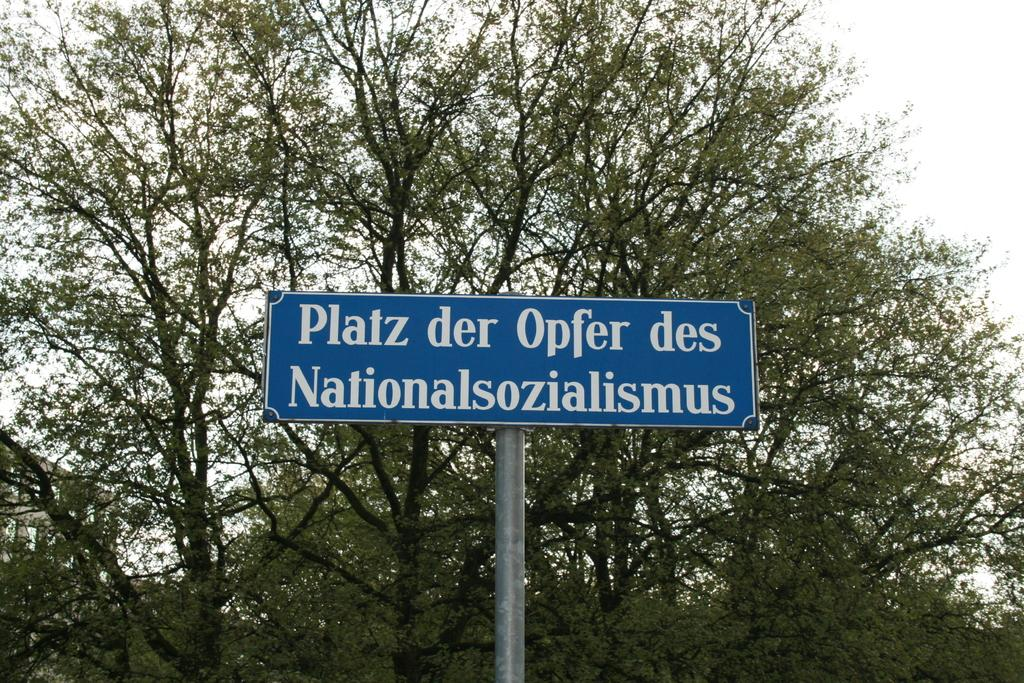What type of vegetation is visible in the image? There are trees in the image. What object is located in the middle of the image? There is a board in the middle of the image. Can you see the son playing with a ray in the image? There is no son or ray present in the image; it only features trees and a board. 